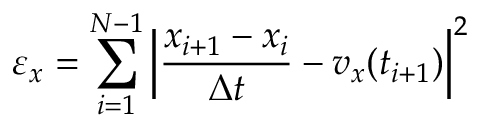Convert formula to latex. <formula><loc_0><loc_0><loc_500><loc_500>{ \varepsilon } _ { x } = \sum _ { i = 1 } ^ { N - 1 } \left | \frac { x _ { i + 1 } - x _ { i } } { \Delta t } - v _ { x } ( t _ { i + 1 } ) \right | ^ { 2 }</formula> 